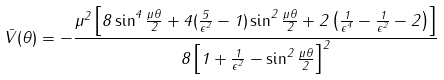<formula> <loc_0><loc_0><loc_500><loc_500>\bar { V } ( \theta ) = - \frac { \mu ^ { 2 } \left [ 8 \sin ^ { 4 } \frac { \mu \theta } { 2 } + 4 ( \frac { 5 } { \epsilon ^ { 2 } } - 1 ) \sin ^ { 2 } \frac { \mu \theta } { 2 } + 2 \left ( \frac { 1 } { \epsilon ^ { 4 } } - \frac { 1 } { \epsilon ^ { 2 } } - 2 \right ) \right ] } { 8 \left [ 1 + \frac { 1 } { \epsilon ^ { 2 } } - \sin ^ { 2 } \frac { \mu \theta } { 2 } \right ] ^ { 2 } }</formula> 